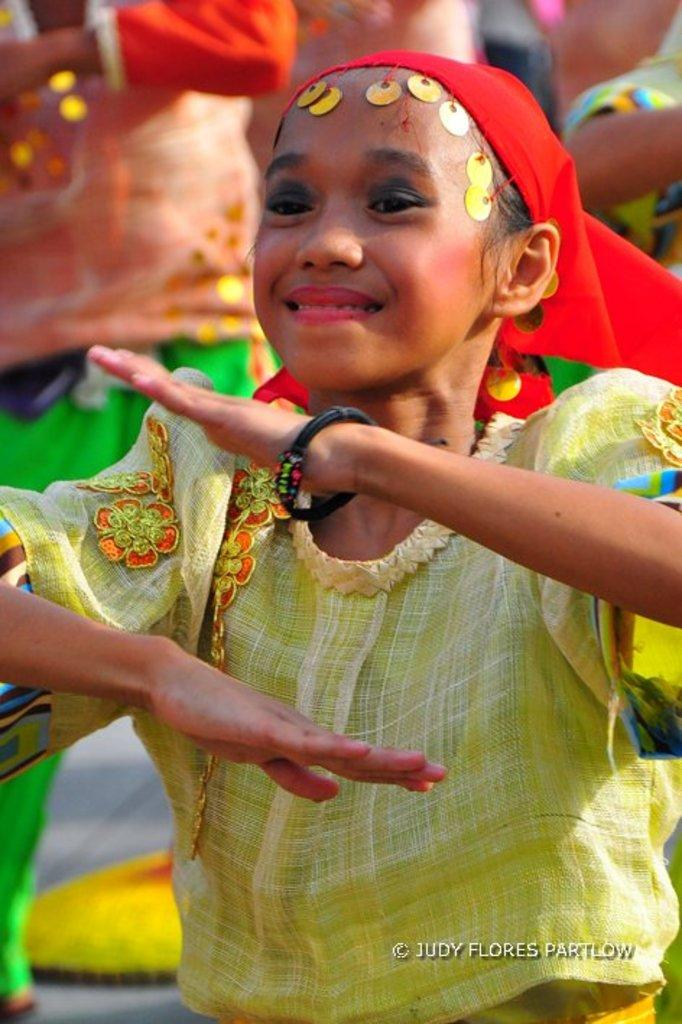What is happening in the image? There are people in the image, and they are dancing. Can you describe the actions of the people in the image? The people are dancing. What type of nut is being used to protest in the image? There is no nut or protest present in the image; it features people dancing. Are there any ghosts visible in the image? There are no ghosts present in the image; it features people dancing. 